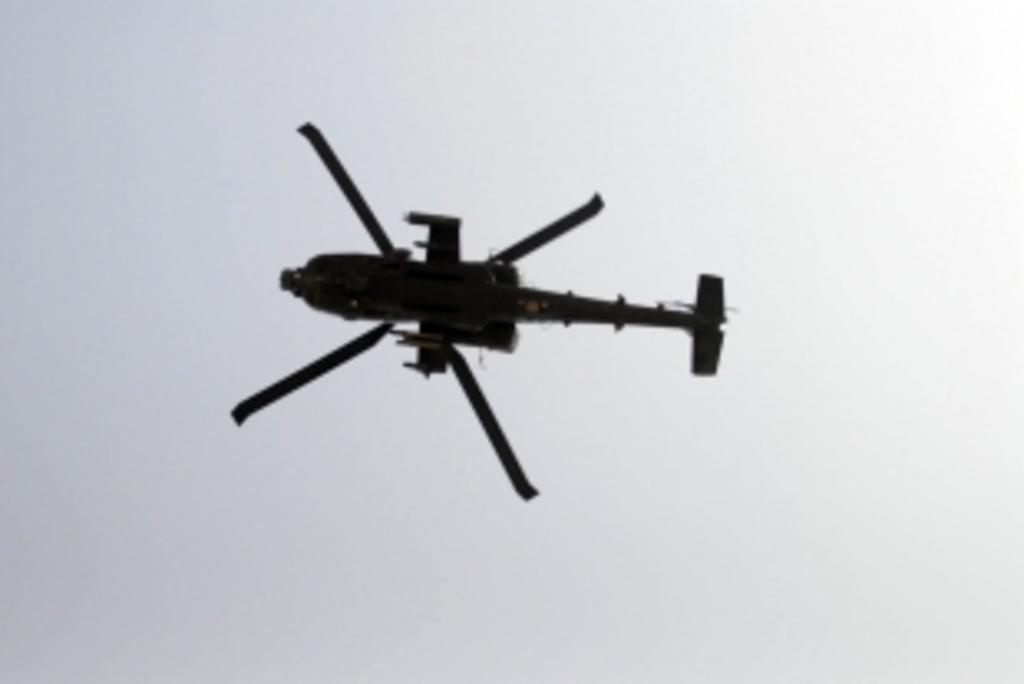What is the main subject of the image? The main subject of the image is an airplane. Where is the airplane located in the image? The airplane is in the center of the image. What can be seen in the background of the image? The sky is visible in the background of the image. Are there any weather conditions depicted in the image? Yes, clouds are present in the background of the image. What type of dust can be seen on the airplane's wings in the image? There is no dust visible on the airplane's wings in the image. Is there a glove or suit present in the image? No, there is no glove or suit present in the image. 